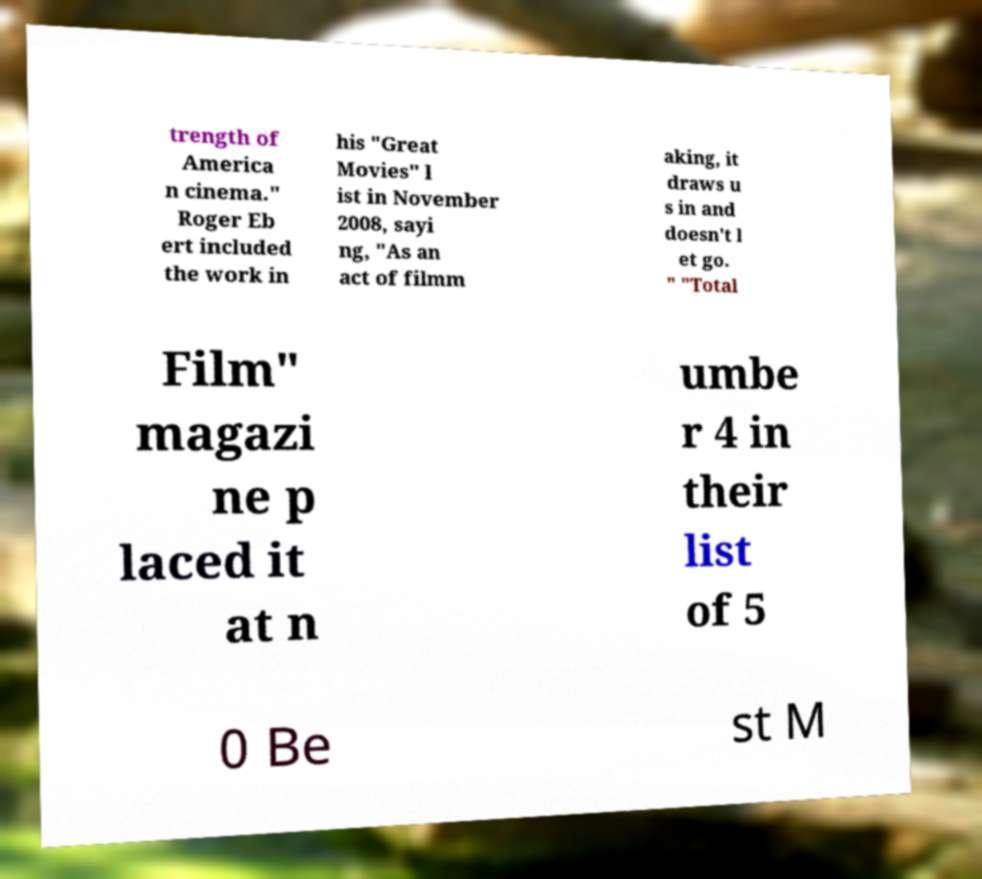Could you extract and type out the text from this image? trength of America n cinema." Roger Eb ert included the work in his "Great Movies" l ist in November 2008, sayi ng, "As an act of filmm aking, it draws u s in and doesn't l et go. " "Total Film" magazi ne p laced it at n umbe r 4 in their list of 5 0 Be st M 